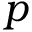<formula> <loc_0><loc_0><loc_500><loc_500>p</formula> 